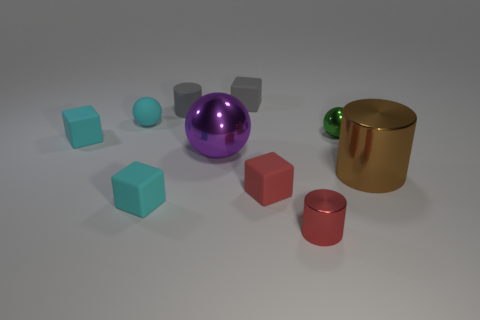Subtract all large spheres. How many spheres are left? 2 Subtract all cyan cubes. How many cubes are left? 2 Subtract 0 yellow cubes. How many objects are left? 10 Subtract all cylinders. How many objects are left? 7 Subtract 3 cylinders. How many cylinders are left? 0 Subtract all red cylinders. Subtract all yellow balls. How many cylinders are left? 2 Subtract all green blocks. How many purple balls are left? 1 Subtract all small rubber balls. Subtract all cyan metallic balls. How many objects are left? 9 Add 7 red shiny objects. How many red shiny objects are left? 8 Add 6 blocks. How many blocks exist? 10 